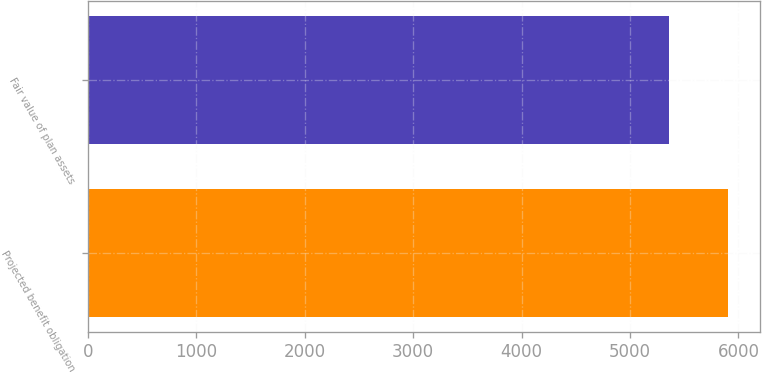Convert chart. <chart><loc_0><loc_0><loc_500><loc_500><bar_chart><fcel>Projected benefit obligation<fcel>Fair value of plan assets<nl><fcel>5900.1<fcel>5357<nl></chart> 